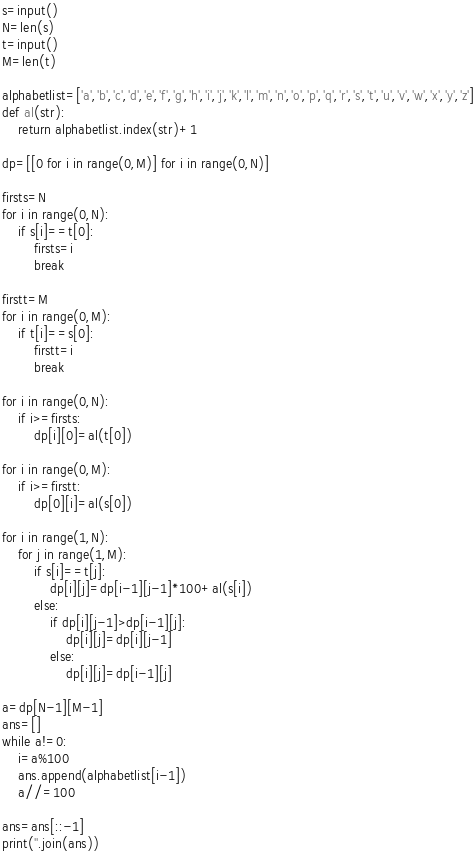<code> <loc_0><loc_0><loc_500><loc_500><_Python_>s=input()
N=len(s)
t=input()
M=len(t)

alphabetlist=['a','b','c','d','e','f','g','h','i','j','k','l','m','n','o','p','q','r','s','t','u','v','w','x','y','z']
def al(str):
    return alphabetlist.index(str)+1

dp=[[0 for i in range(0,M)] for i in range(0,N)]

firsts=N
for i in range(0,N):
    if s[i]==t[0]:
        firsts=i
        break

firstt=M
for i in range(0,M):
    if t[i]==s[0]:
        firstt=i
        break

for i in range(0,N):
    if i>=firsts:
        dp[i][0]=al(t[0])

for i in range(0,M):
    if i>=firstt:
        dp[0][i]=al(s[0])

for i in range(1,N):
    for j in range(1,M):
        if s[i]==t[j]:
            dp[i][j]=dp[i-1][j-1]*100+al(s[i])
        else:
            if dp[i][j-1]>dp[i-1][j]:
                dp[i][j]=dp[i][j-1]
            else:
                dp[i][j]=dp[i-1][j]

a=dp[N-1][M-1]
ans=[]
while a!=0:
    i=a%100
    ans.append(alphabetlist[i-1])
    a//=100

ans=ans[::-1]
print(''.join(ans))</code> 